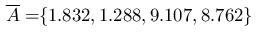<formula> <loc_0><loc_0><loc_500><loc_500>\, \overline { A } = \, \{ 1 . 8 3 2 , 1 . 2 8 8 , 9 . 1 0 7 , 8 . 7 6 2 \} \,</formula> 